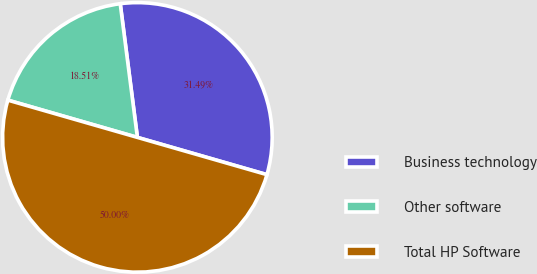<chart> <loc_0><loc_0><loc_500><loc_500><pie_chart><fcel>Business technology<fcel>Other software<fcel>Total HP Software<nl><fcel>31.49%<fcel>18.51%<fcel>50.0%<nl></chart> 